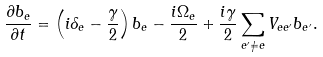Convert formula to latex. <formula><loc_0><loc_0><loc_500><loc_500>\frac { \partial b _ { e } } { \partial t } = \left ( i \delta _ { e } - \frac { \gamma } { 2 } \right ) b _ { e } - \frac { i \Omega _ { e } } { 2 } + \frac { i \gamma } { 2 } \sum _ { e ^ { \prime } \neq e } V _ { e e ^ { \prime } } b _ { e ^ { \prime } } .</formula> 